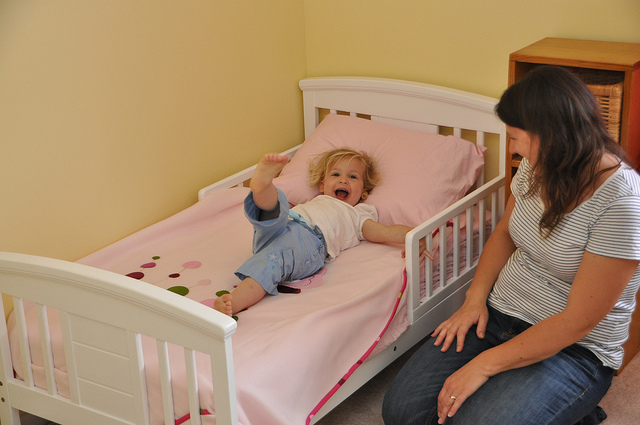<image>Which child is not smiling? It is unknown which child is not smiling. All children could be smiling. Why does she have her leg up? I don't know why she has her leg up. She could be playing, kicking, pointing, or showing it to the camera. Which child is not smiling? It is unanswerable which child is not smiling. All the children in the image are smiling. Why does she have her leg up? I don't know why she has her leg up. It can be seen as kicking, playing, or pointing. 